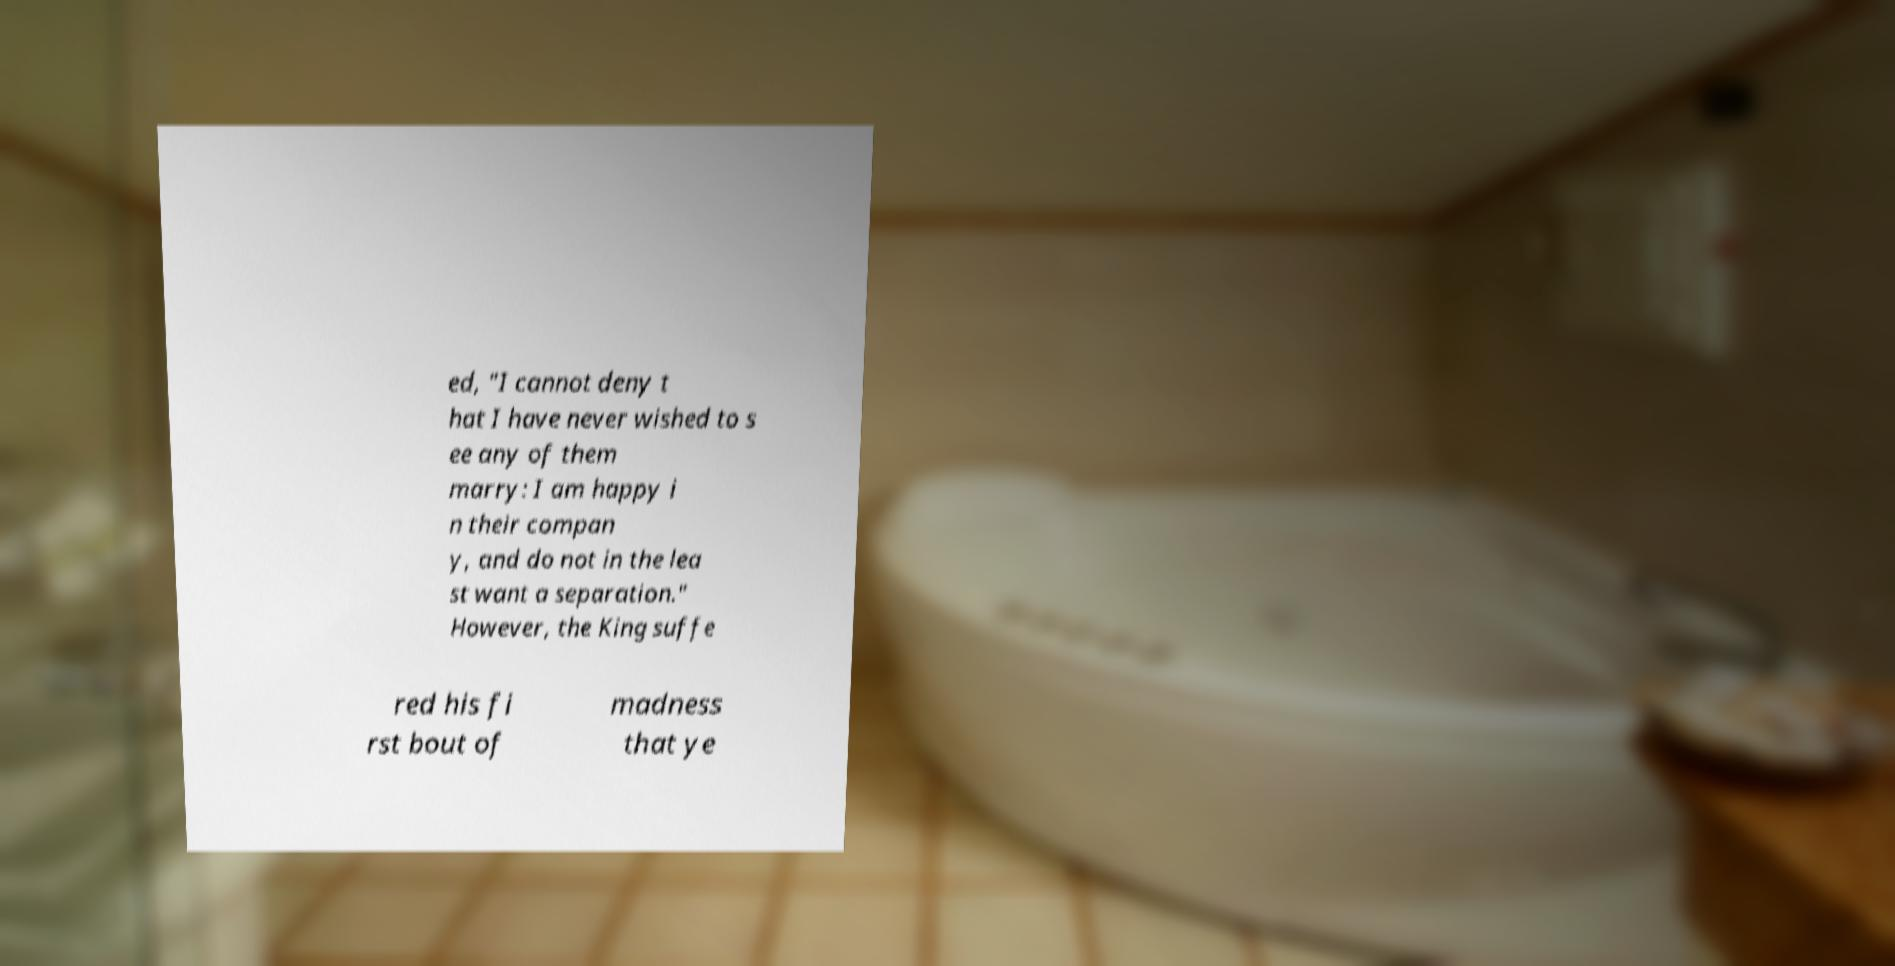Could you extract and type out the text from this image? ed, "I cannot deny t hat I have never wished to s ee any of them marry: I am happy i n their compan y, and do not in the lea st want a separation." However, the King suffe red his fi rst bout of madness that ye 